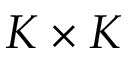<formula> <loc_0><loc_0><loc_500><loc_500>K \times K</formula> 